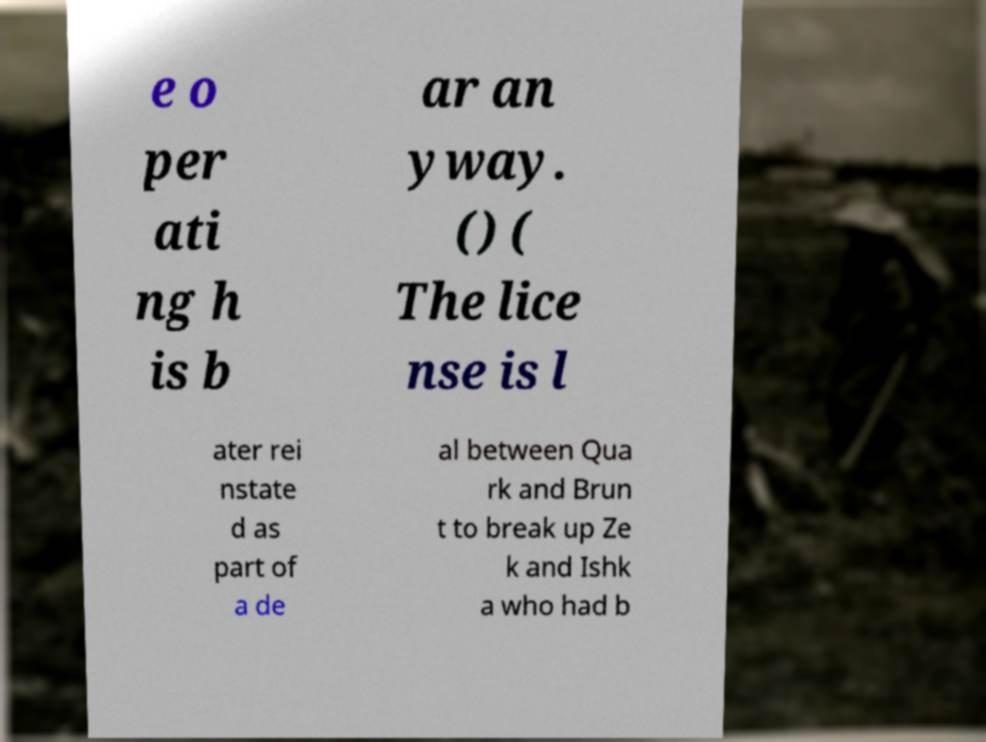I need the written content from this picture converted into text. Can you do that? e o per ati ng h is b ar an yway. () ( The lice nse is l ater rei nstate d as part of a de al between Qua rk and Brun t to break up Ze k and Ishk a who had b 